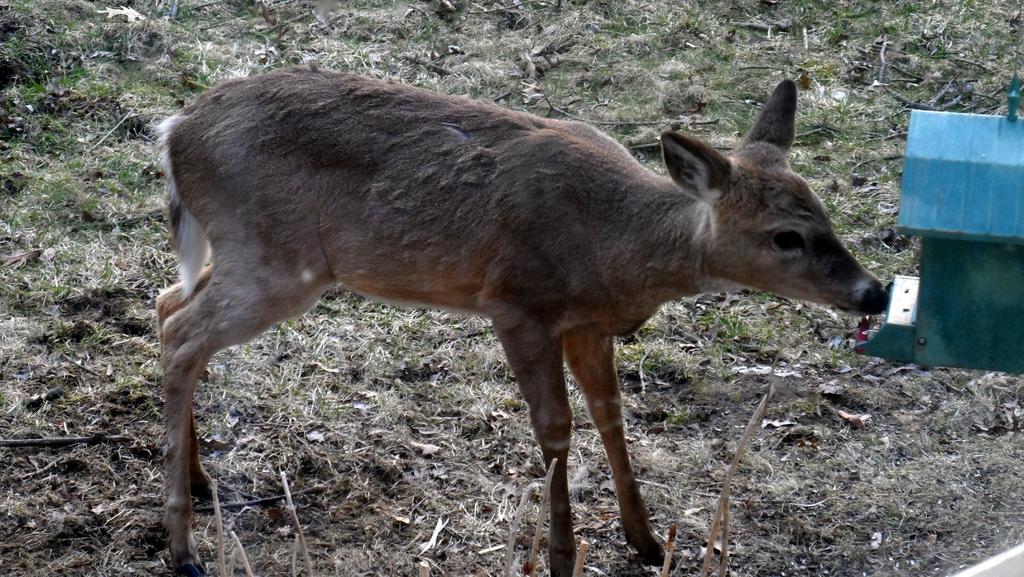Describe this image in one or two sentences. This is the picture of a deer which is on the floor which has some grass. 